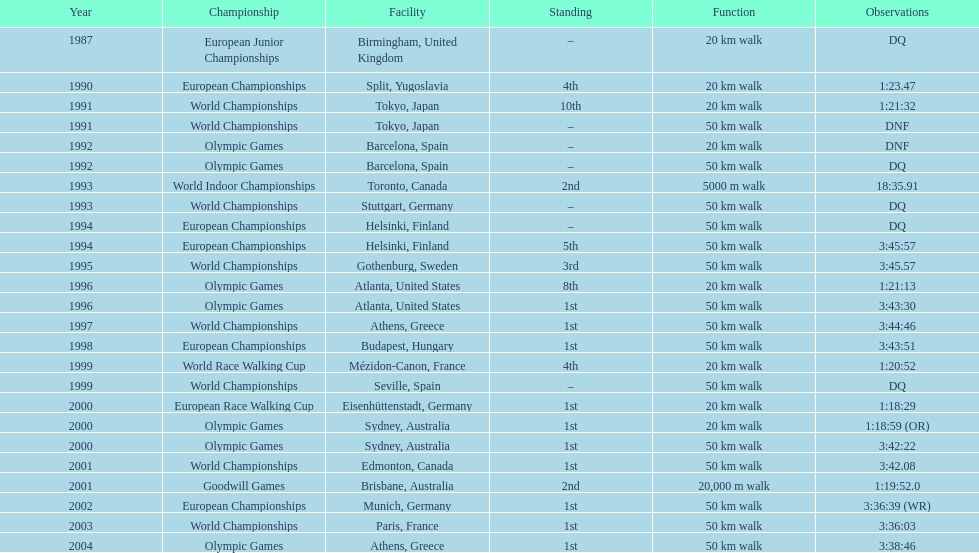In what year was korzeniowski's last competition? 2004. 